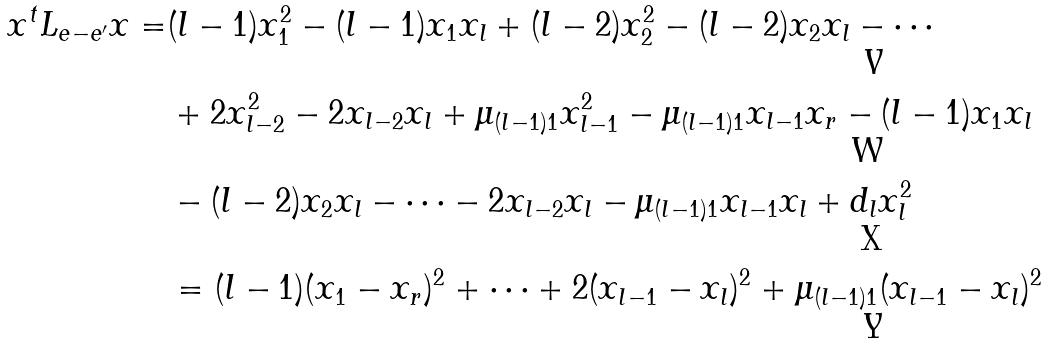Convert formula to latex. <formula><loc_0><loc_0><loc_500><loc_500>x ^ { t } L _ { e - e ^ { \prime } } x = & ( l - 1 ) x ^ { 2 } _ { 1 } - ( l - 1 ) x _ { 1 } x _ { l } + ( l - 2 ) x ^ { 2 } _ { 2 } - ( l - 2 ) x _ { 2 } x _ { l } - \cdots \\ & + 2 x ^ { 2 } _ { l - 2 } - 2 x _ { l - 2 } x _ { l } + \mu _ { ( l - 1 ) 1 } x ^ { 2 } _ { l - 1 } - \mu _ { ( l - 1 ) 1 } x _ { l - 1 } x _ { r } - ( l - 1 ) x _ { 1 } x _ { l } \\ & - ( l - 2 ) x _ { 2 } x _ { l } - \cdots - 2 x _ { l - 2 } x _ { l } - \mu _ { ( l - 1 ) 1 } x _ { l - 1 } x _ { l } + d _ { l } x ^ { 2 } _ { l } \\ & = ( l - 1 ) ( x _ { 1 } - x _ { r } ) ^ { 2 } + \cdots + 2 ( x _ { l - 1 } - x _ { l } ) ^ { 2 } + \mu _ { ( l - 1 ) 1 } ( x _ { l - 1 } - x _ { l } ) ^ { 2 }</formula> 